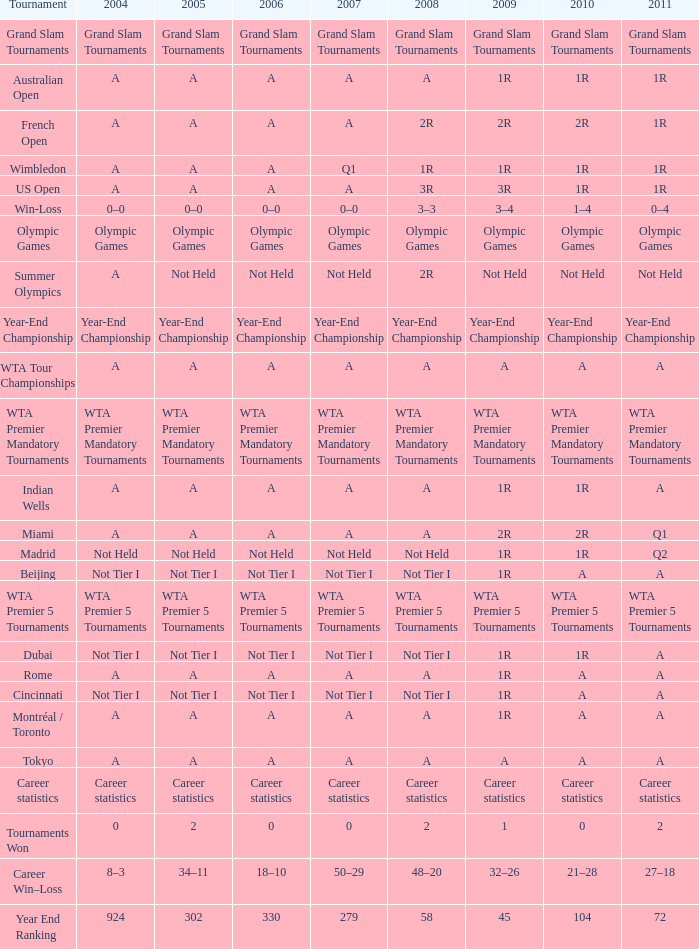What is 2011, when 2006 is "A", when 2008 is "A", and when Tournament is "Rome"? A. 